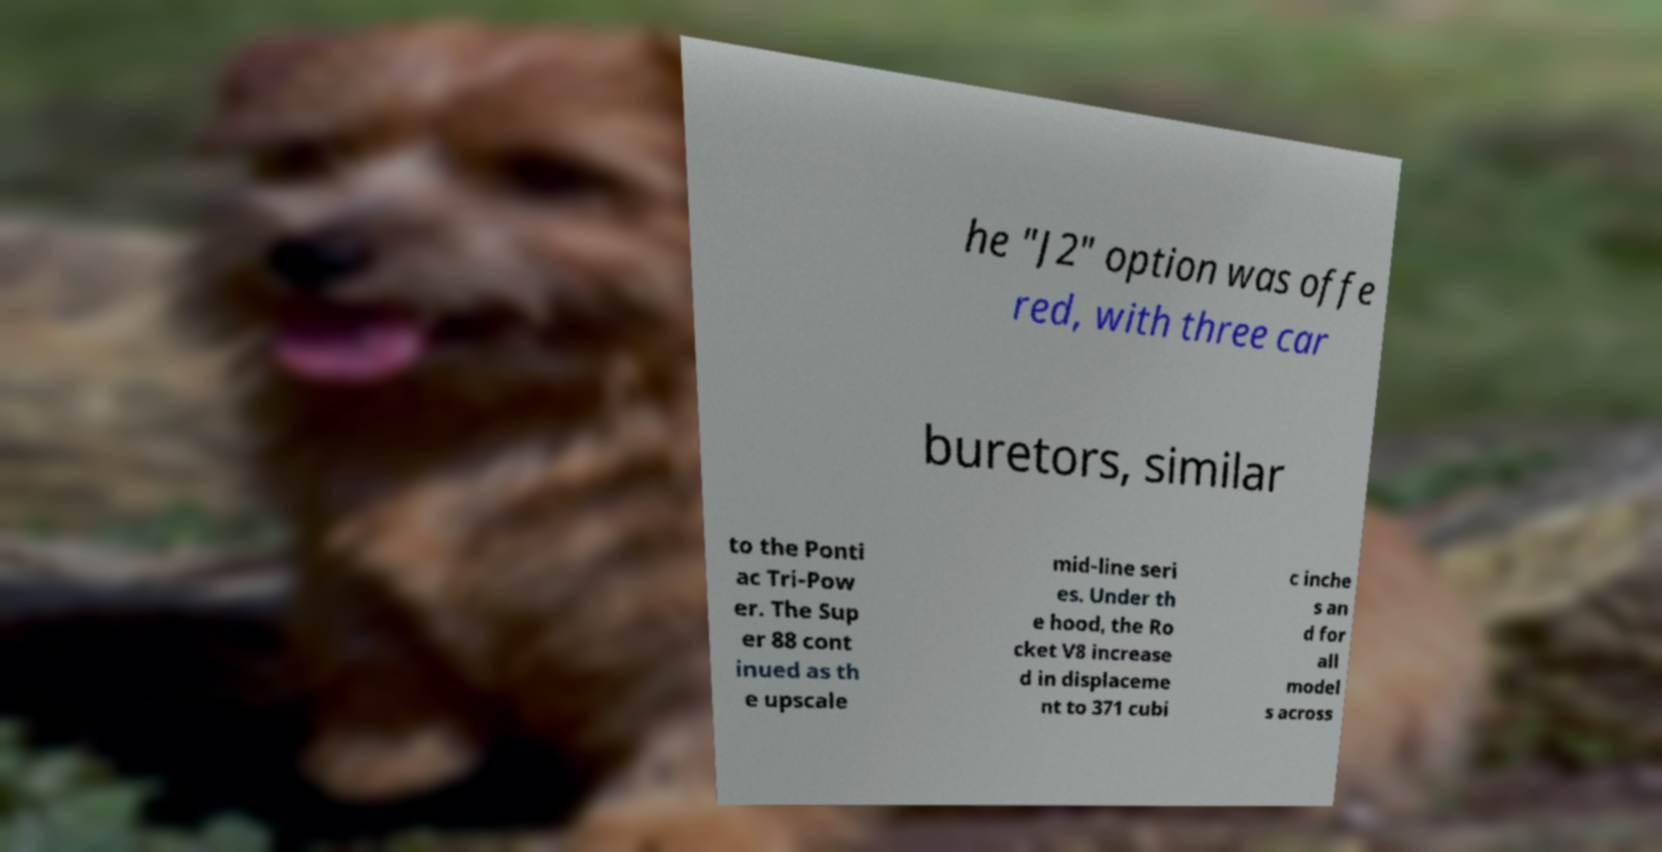Can you read and provide the text displayed in the image?This photo seems to have some interesting text. Can you extract and type it out for me? he "J2" option was offe red, with three car buretors, similar to the Ponti ac Tri-Pow er. The Sup er 88 cont inued as th e upscale mid-line seri es. Under th e hood, the Ro cket V8 increase d in displaceme nt to 371 cubi c inche s an d for all model s across 